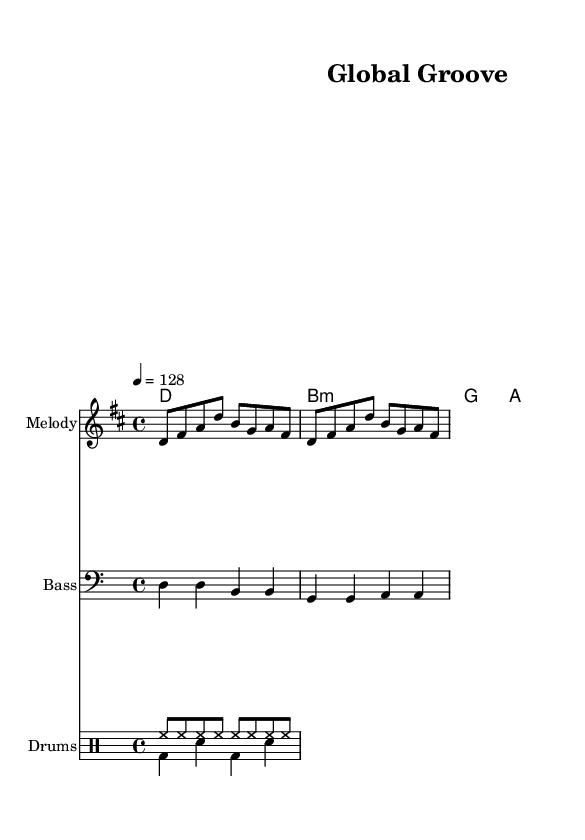What is the key signature of this music? The key signature is indicated at the beginning of the score, showing that it has two sharps. This corresponds to the key of D major.
Answer: D major What is the time signature of this music? The time signature appears at the beginning of the score, which indicates there are four beats in each measure, denoted by the fraction 4/4.
Answer: 4/4 What is the tempo marking for this piece? The tempo is indicated in the score, set at 128 beats per minute. This is specified right after the time signature.
Answer: 128 How many measures are present in the melody section? The melody is structured over several measures, and counting the bars leads to a total of four measures spanning the given note sequences.
Answer: 4 What instrument is primarily featured in the melody? The score designates a specific staff for the melody. It is usually played by an individual high-pitched instrument, commonly representing a lead, identified as "Melody".
Answer: Melody What type of rhythm is predominantly used in the drum pattern? The drum patterns consist of various note durations, and analyzing them reveals that the main rhythm primarily consists of eighth notes for the hi-hat and a standard bass-snare pattern.
Answer: Eighth notes Why is this piece categorized as a dance track? The composition is characterized by an upbeat tempo, repetitive rhythmic patterns, and a groove that encourages movement, all of which are essential elements of dance music.
Answer: Upbeat 